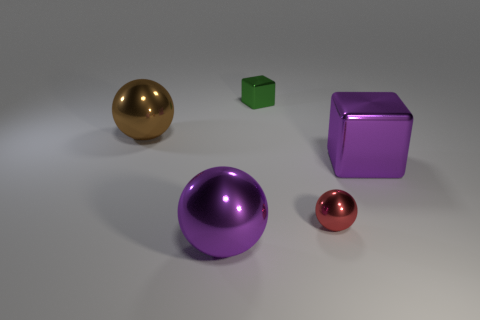Is there anything else that is the same size as the purple cube?
Provide a short and direct response. Yes. What material is the cube right of the green metal thing?
Offer a very short reply. Metal. What number of purple blocks have the same material as the small green thing?
Your answer should be very brief. 1. The large metal thing that is both behind the big purple ball and on the right side of the large brown object has what shape?
Your response must be concise. Cube. How many things are shiny objects right of the small green block or large purple metallic objects left of the green shiny thing?
Provide a succinct answer. 3. Are there the same number of big brown spheres that are to the right of the green cube and big brown balls in front of the brown object?
Offer a terse response. Yes. What shape is the large metallic object behind the big purple thing that is behind the tiny red metal sphere?
Your answer should be compact. Sphere. Is there a purple shiny object that has the same shape as the large brown metal thing?
Your answer should be compact. Yes. What number of red objects are there?
Provide a short and direct response. 1. Is the material of the ball that is on the right side of the green metal block the same as the large purple block?
Offer a terse response. Yes. 